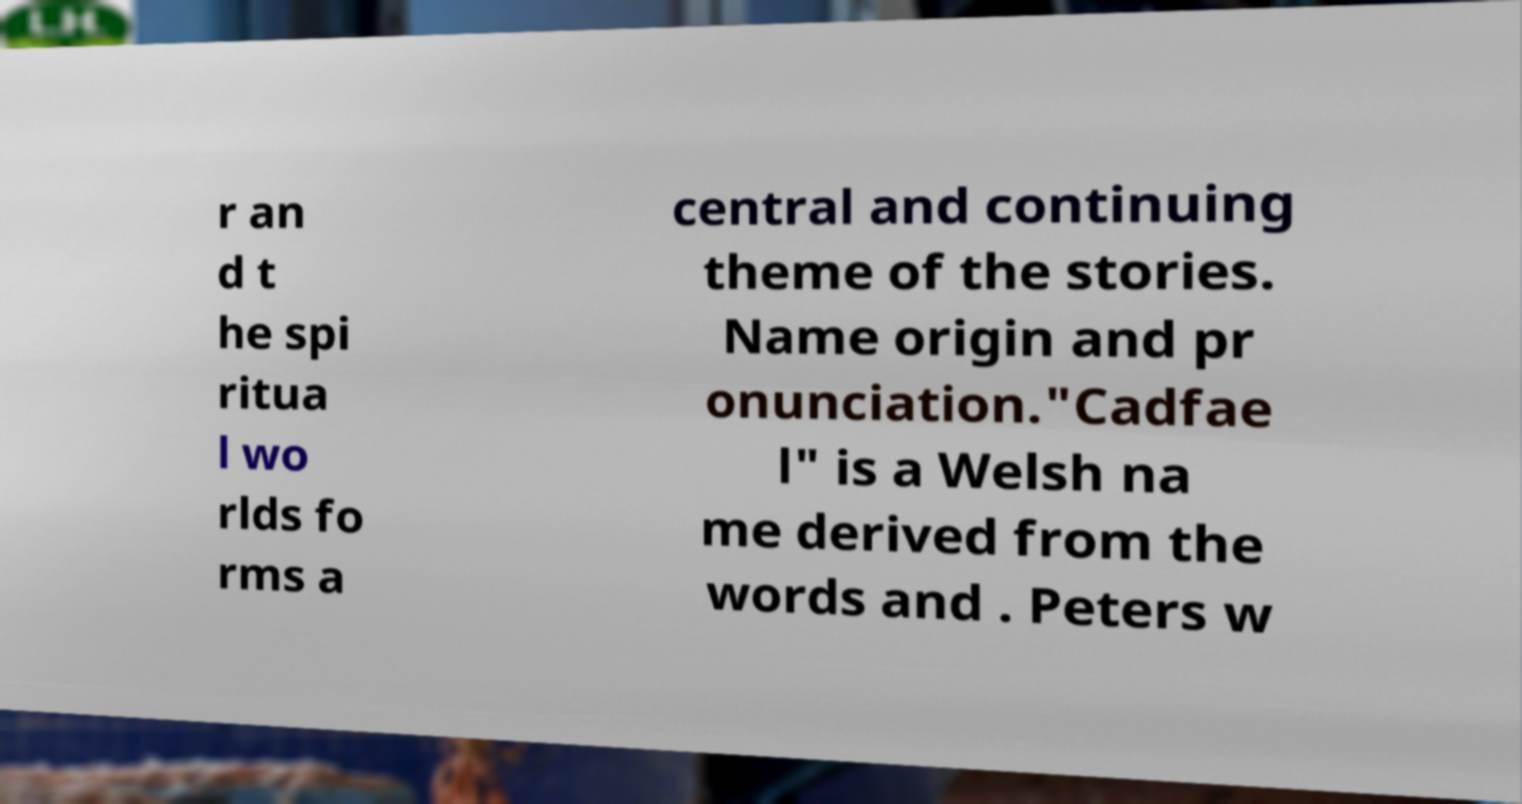Could you extract and type out the text from this image? r an d t he spi ritua l wo rlds fo rms a central and continuing theme of the stories. Name origin and pr onunciation."Cadfae l" is a Welsh na me derived from the words and . Peters w 